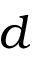<formula> <loc_0><loc_0><loc_500><loc_500>d</formula> 